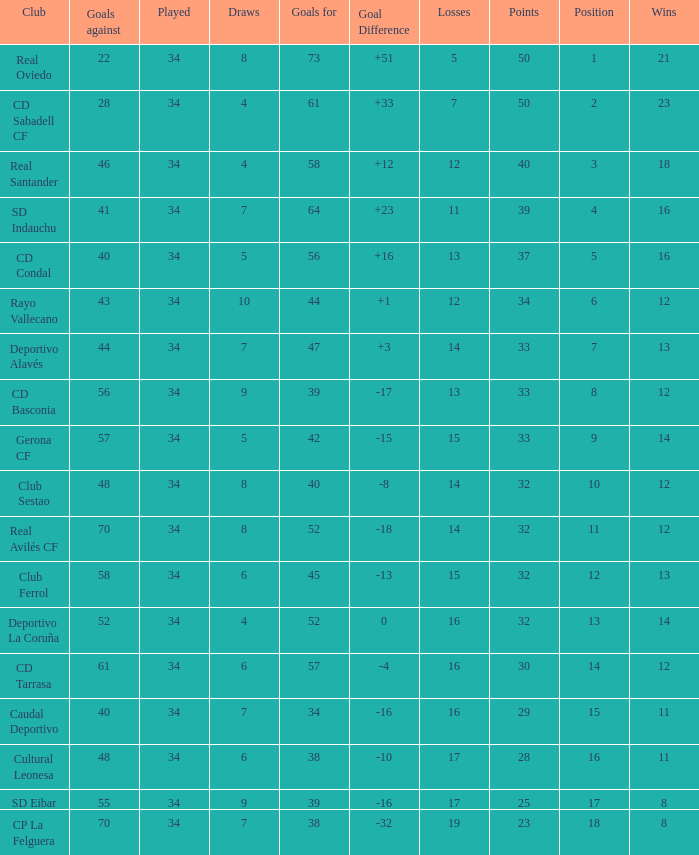Which Wins have a Goal Difference larger than 0, and Goals against larger than 40, and a Position smaller than 6, and a Club of sd indauchu? 16.0. 